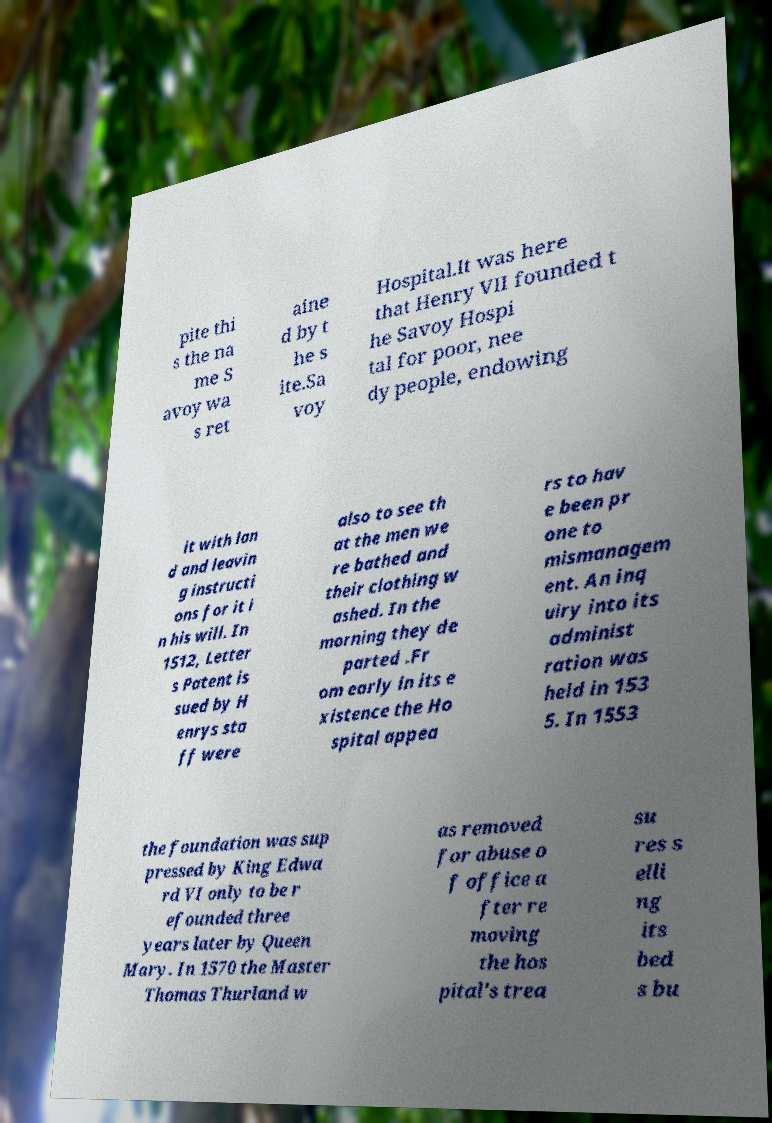Can you read and provide the text displayed in the image?This photo seems to have some interesting text. Can you extract and type it out for me? pite thi s the na me S avoy wa s ret aine d by t he s ite.Sa voy Hospital.It was here that Henry VII founded t he Savoy Hospi tal for poor, nee dy people, endowing it with lan d and leavin g instructi ons for it i n his will. In 1512, Letter s Patent is sued by H enrys sta ff were also to see th at the men we re bathed and their clothing w ashed. In the morning they de parted .Fr om early in its e xistence the Ho spital appea rs to hav e been pr one to mismanagem ent. An inq uiry into its administ ration was held in 153 5. In 1553 the foundation was sup pressed by King Edwa rd VI only to be r efounded three years later by Queen Mary. In 1570 the Master Thomas Thurland w as removed for abuse o f office a fter re moving the hos pital's trea su res s elli ng its bed s bu 